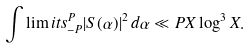Convert formula to latex. <formula><loc_0><loc_0><loc_500><loc_500>\int \lim i t s _ { - P } ^ { P } | S ( \alpha ) | ^ { 2 } \, d \alpha \ll P X \log ^ { 3 } X .</formula> 